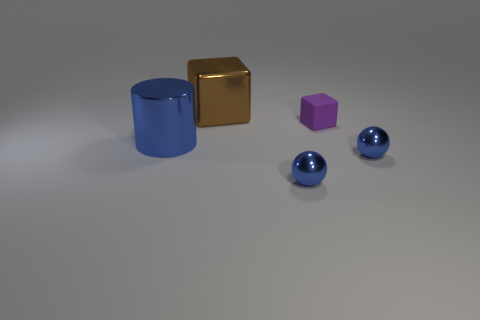There is a tiny metal ball that is on the left side of the small purple thing; is there a tiny ball that is behind it?
Offer a terse response. Yes. There is a big shiny object that is right of the big metallic thing left of the large brown metal object; what number of metallic objects are to the right of it?
Ensure brevity in your answer.  2. Are there fewer rubber blocks than small blue metallic things?
Your answer should be compact. Yes. There is a purple matte object that is behind the metal cylinder; does it have the same shape as the blue thing that is right of the small matte thing?
Your response must be concise. No. What is the color of the small matte thing?
Ensure brevity in your answer.  Purple. What number of matte things are red things or big brown objects?
Offer a terse response. 0. The metallic thing that is the same shape as the tiny matte object is what color?
Offer a terse response. Brown. Is there a tiny purple thing?
Give a very brief answer. Yes. Is the big object that is behind the metallic cylinder made of the same material as the block that is on the right side of the big block?
Provide a succinct answer. No. How many objects are either blocks that are in front of the shiny block or things that are left of the tiny matte object?
Your answer should be compact. 4. 